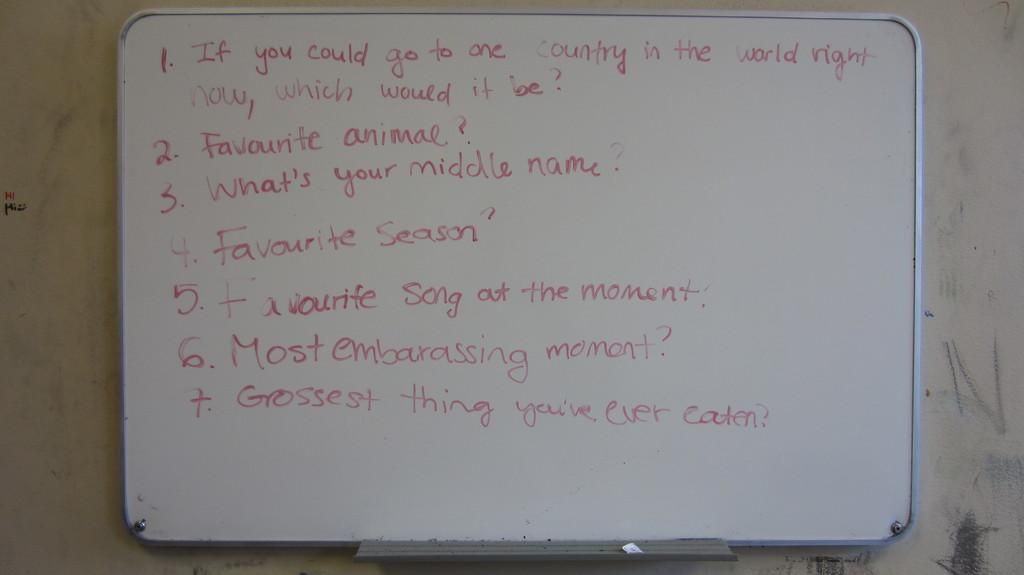<image>
Relay a brief, clear account of the picture shown. A whiteboard asks a number of questions, including "Favourite animal?" 